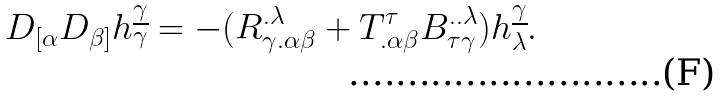<formula> <loc_0><loc_0><loc_500><loc_500>D _ { [ { \alpha } } D _ { { \beta } ] } h ^ { \underline { \gamma } } _ { \gamma } = - ( R ^ { { . } { \lambda } } _ { { \gamma } { . } { \alpha } { \beta } } + T ^ { \tau } _ { { . } { \alpha } { \beta } } B ^ { { . . } { \lambda } } _ { { \tau } { \gamma } } ) h ^ { \underline { \gamma } } _ { \lambda } .</formula> 